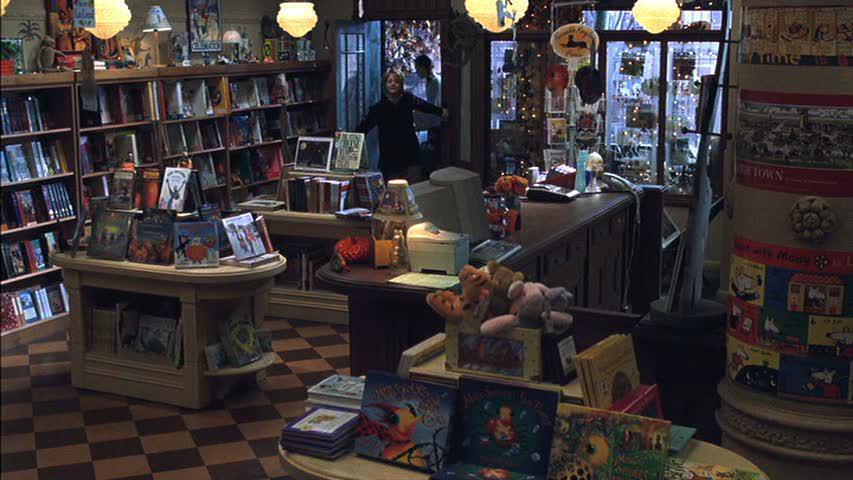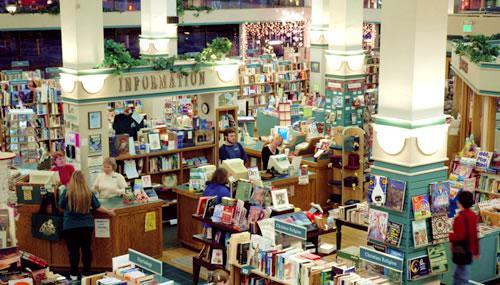The first image is the image on the left, the second image is the image on the right. For the images displayed, is the sentence "Both images shown the exterior of a bookstore." factually correct? Answer yes or no. No. The first image is the image on the left, the second image is the image on the right. Analyze the images presented: Is the assertion "An image shows multiple non-hanging containers of flowering plants in front of a shop's exterior." valid? Answer yes or no. No. 